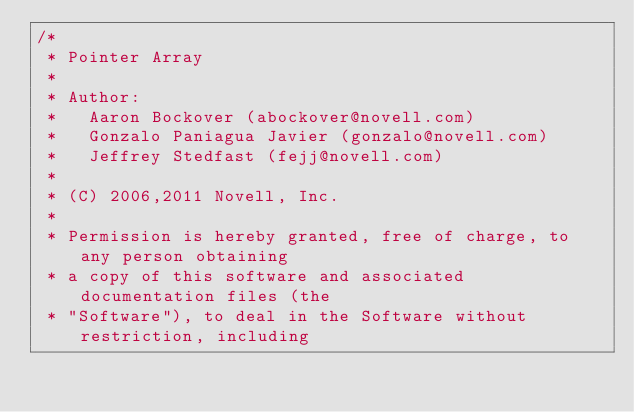<code> <loc_0><loc_0><loc_500><loc_500><_C_>/*
 * Pointer Array
 *
 * Author:
 *   Aaron Bockover (abockover@novell.com)
 *   Gonzalo Paniagua Javier (gonzalo@novell.com)
 *   Jeffrey Stedfast (fejj@novell.com)
 *
 * (C) 2006,2011 Novell, Inc.
 *
 * Permission is hereby granted, free of charge, to any person obtaining
 * a copy of this software and associated documentation files (the
 * "Software"), to deal in the Software without restriction, including</code> 